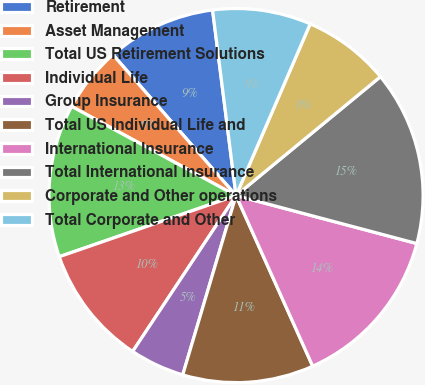Convert chart to OTSL. <chart><loc_0><loc_0><loc_500><loc_500><pie_chart><fcel>Retirement<fcel>Asset Management<fcel>Total US Retirement Solutions<fcel>Individual Life<fcel>Group Insurance<fcel>Total US Individual Life and<fcel>International Insurance<fcel>Total International Insurance<fcel>Corporate and Other operations<fcel>Total Corporate and Other<nl><fcel>9.43%<fcel>5.66%<fcel>13.21%<fcel>10.38%<fcel>4.72%<fcel>11.32%<fcel>14.15%<fcel>15.09%<fcel>7.55%<fcel>8.49%<nl></chart> 